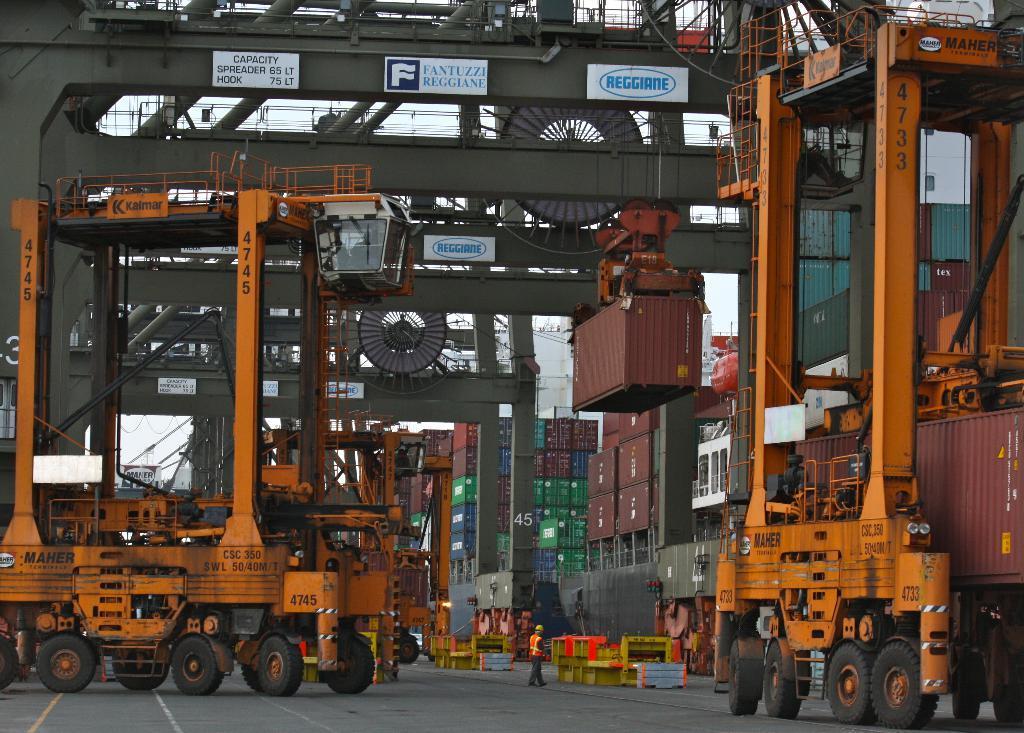Describe this image in one or two sentences. In this image I can see trucks, vehicles and a crowd on the floor. In the background I can see machines, boxes and so on. This image is taken may be in a factory. 